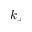Convert formula to latex. <formula><loc_0><loc_0><loc_500><loc_500>k _ { + }</formula> 